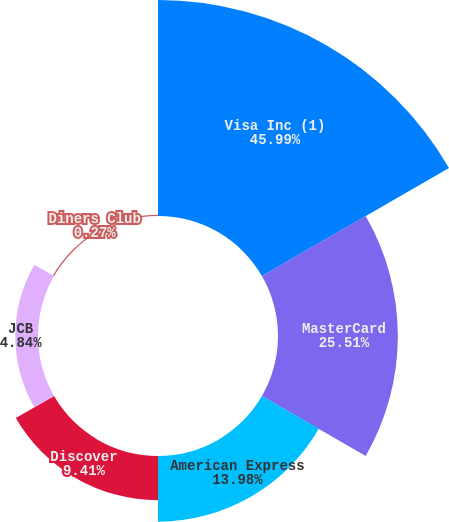Convert chart to OTSL. <chart><loc_0><loc_0><loc_500><loc_500><pie_chart><fcel>Visa Inc (1)<fcel>MasterCard<fcel>American Express<fcel>Discover<fcel>JCB<fcel>Diners Club<nl><fcel>45.98%<fcel>25.51%<fcel>13.98%<fcel>9.41%<fcel>4.84%<fcel>0.27%<nl></chart> 